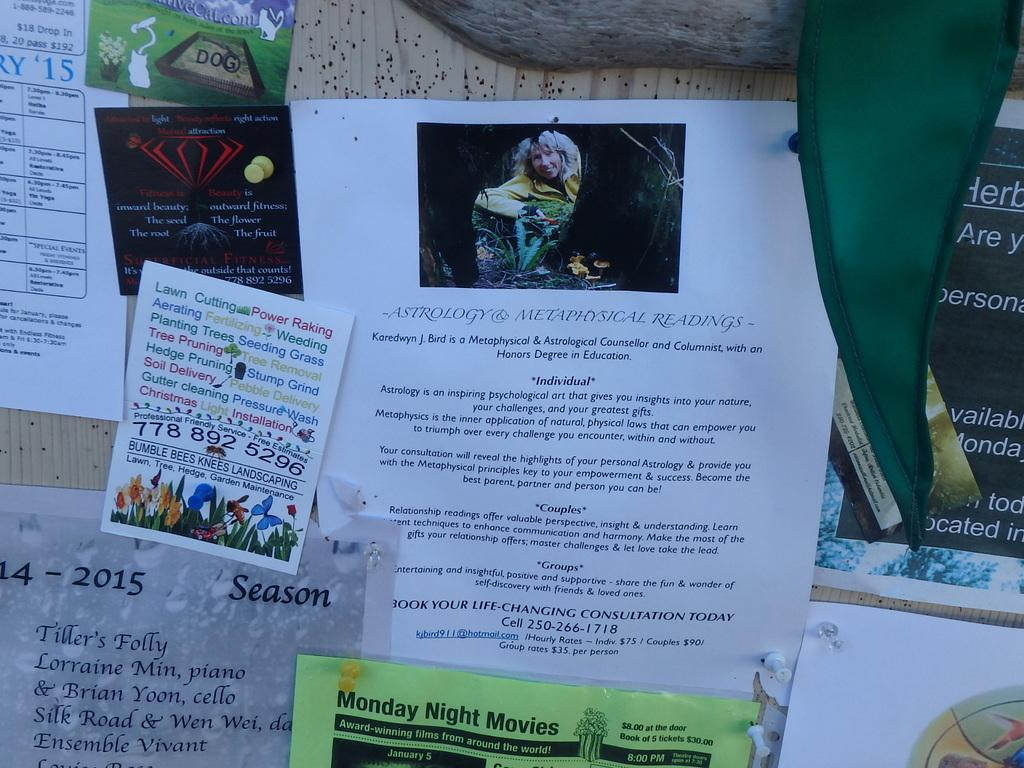Provide a one-sentence caption for the provided image. A bulletin board has several advertisements including astrology and metaphysical reading services. 